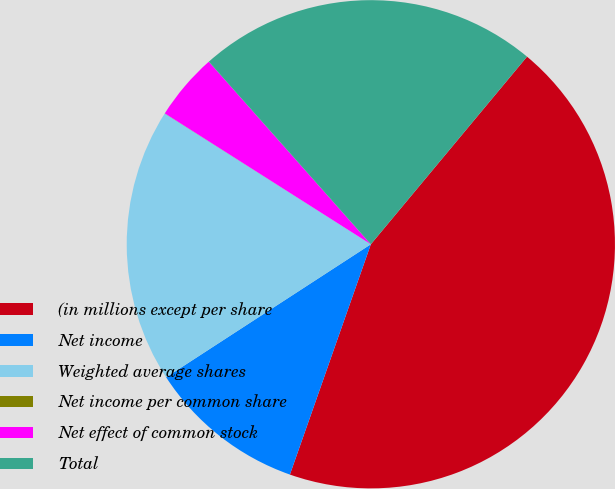Convert chart to OTSL. <chart><loc_0><loc_0><loc_500><loc_500><pie_chart><fcel>(in millions except per share<fcel>Net income<fcel>Weighted average shares<fcel>Net income per common share<fcel>Net effect of common stock<fcel>Total<nl><fcel>44.33%<fcel>10.45%<fcel>18.17%<fcel>0.01%<fcel>4.44%<fcel>22.6%<nl></chart> 